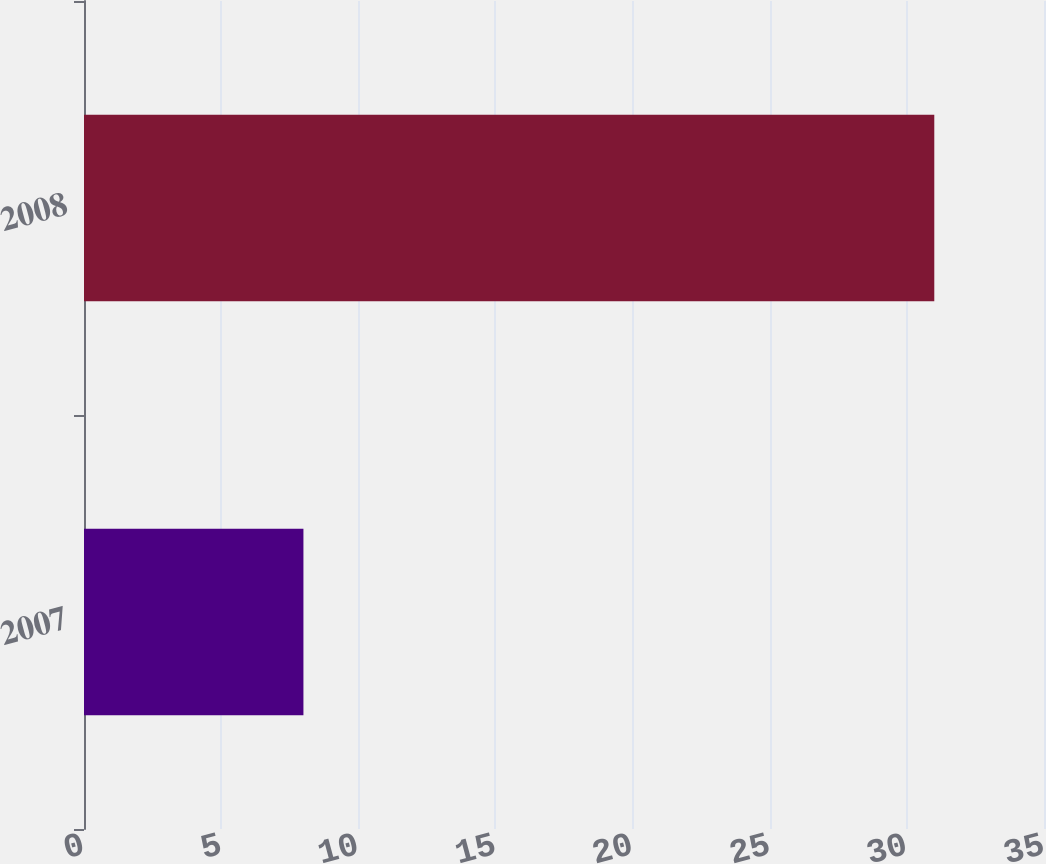Convert chart. <chart><loc_0><loc_0><loc_500><loc_500><bar_chart><fcel>2007<fcel>2008<nl><fcel>8<fcel>31<nl></chart> 